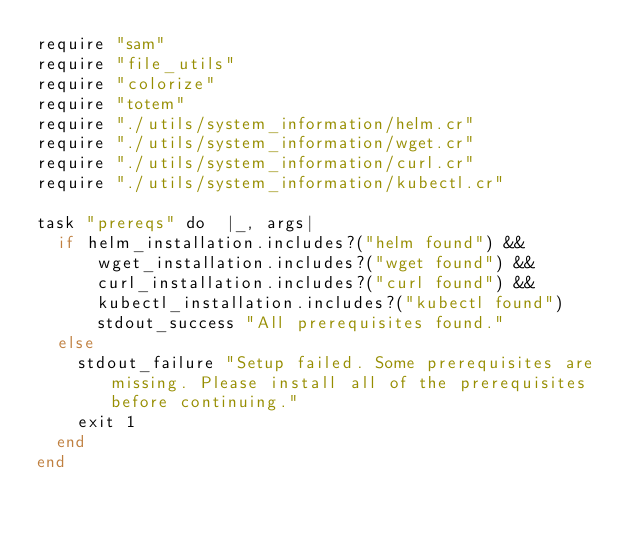<code> <loc_0><loc_0><loc_500><loc_500><_Crystal_>require "sam"
require "file_utils"
require "colorize"
require "totem"
require "./utils/system_information/helm.cr"
require "./utils/system_information/wget.cr"
require "./utils/system_information/curl.cr"
require "./utils/system_information/kubectl.cr"

task "prereqs" do  |_, args|
  if helm_installation.includes?("helm found") &&
      wget_installation.includes?("wget found") &&
      curl_installation.includes?("curl found") &&
      kubectl_installation.includes?("kubectl found")
      stdout_success "All prerequisites found."
  else
    stdout_failure "Setup failed. Some prerequisites are missing. Please install all of the prerequisites before continuing."
    exit 1
  end
end

</code> 